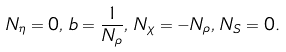Convert formula to latex. <formula><loc_0><loc_0><loc_500><loc_500>N _ { \eta } = 0 , \, b = \frac { 1 } { N _ { \rho } } , \, N _ { \chi } = - N _ { \rho } , \, N _ { S } = 0 .</formula> 